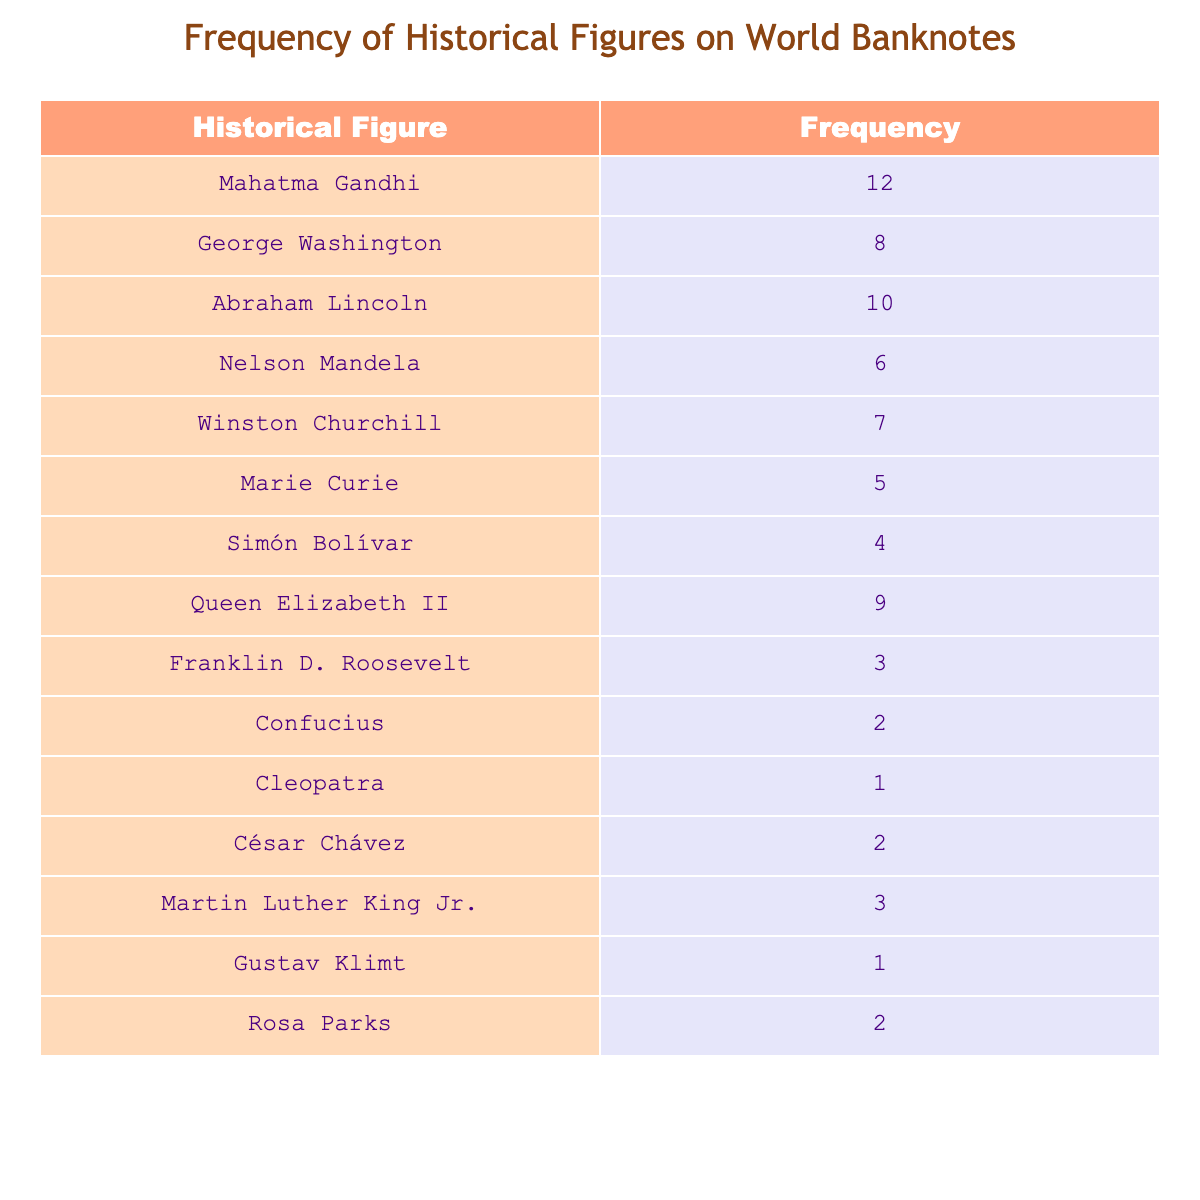What's the frequency of Mahatma Gandhi depicted on world banknotes? The table lists Mahatma Gandhi with a frequency of 12.
Answer: 12 Which historical figure has the highest frequency on world banknotes? Mahatma Gandhi has the highest frequency with a count of 12 compared to others in the table.
Answer: Mahatma Gandhi What is the total frequency of Abraham Lincoln and George Washington combined? To find the total, add Abraham Lincoln's frequency (10) and George Washington's (8): 10 + 8 = 18.
Answer: 18 Is there any historical figure on world banknotes with a frequency of 1? The table shows Cleopatra and Gustav Klimt each have a frequency of 1. So yes, there are figures with that frequency.
Answer: Yes How many more frequencies does Queen Elizabeth II have compared to Nelson Mandela? Queen Elizabeth II has a frequency of 9 and Nelson Mandela has 6. 9 minus 6 equals 3. Therefore, Queen Elizabeth II has 3 more.
Answer: 3 What is the average frequency of the historical figures listed in the table? First, sum all the frequencies: 12 + 8 + 10 + 6 + 7 + 5 + 4 + 9 + 3 + 2 + 1 + 2 + 3 + 1 + 2 = 70. There are 15 figures, so the average is 70 divided by 15, which equals approximately 4.67.
Answer: 4.67 Which historical figures are depicted on world banknotes with a frequency of 2? The table shows Confucius, César Chávez, and Rosa Parks, each with a frequency of 2.
Answer: Confucius, César Chávez, Rosa Parks What is the difference in frequency between the most frequently depicted figure and the least frequently depicted figure? The most frequently depicted figure is Mahatma Gandhi (12) and the least frequently depicted figure is Cleopatra (1). Subtract 1 from 12 to get a difference of 11.
Answer: 11 Are there any historical figures with a frequency of 3? Yes, both Franklin D. Roosevelt and Martin Luther King Jr. are depicted with a frequency of 3.
Answer: Yes 